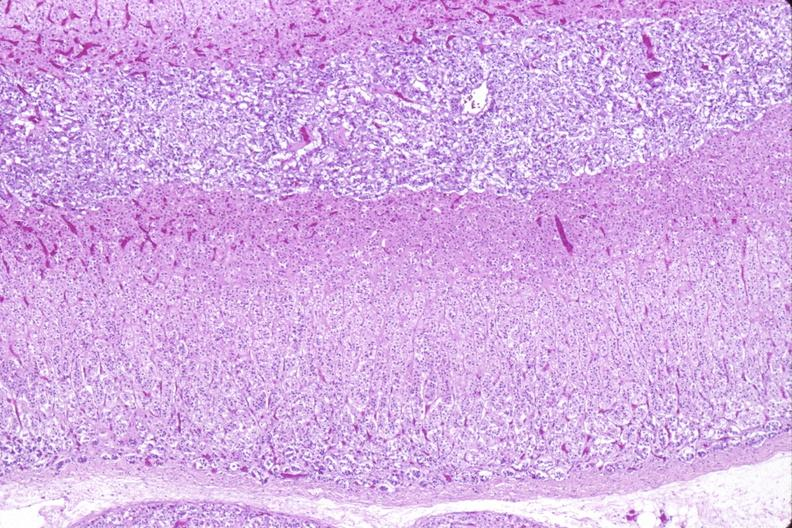s omentum present?
Answer the question using a single word or phrase. No 